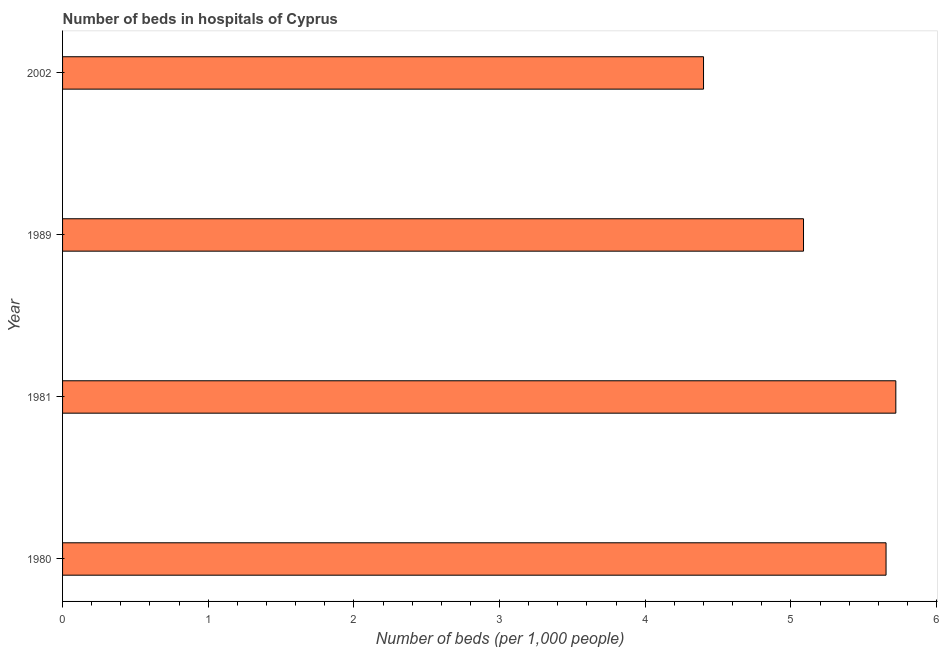Does the graph contain grids?
Ensure brevity in your answer.  No. What is the title of the graph?
Make the answer very short. Number of beds in hospitals of Cyprus. What is the label or title of the X-axis?
Make the answer very short. Number of beds (per 1,0 people). What is the label or title of the Y-axis?
Offer a very short reply. Year. What is the number of hospital beds in 2002?
Ensure brevity in your answer.  4.4. Across all years, what is the maximum number of hospital beds?
Give a very brief answer. 5.72. Across all years, what is the minimum number of hospital beds?
Your answer should be compact. 4.4. In which year was the number of hospital beds maximum?
Your answer should be compact. 1981. What is the sum of the number of hospital beds?
Your answer should be compact. 20.86. What is the difference between the number of hospital beds in 1980 and 2002?
Give a very brief answer. 1.25. What is the average number of hospital beds per year?
Your answer should be very brief. 5.21. What is the median number of hospital beds?
Offer a terse response. 5.37. In how many years, is the number of hospital beds greater than 5.6 %?
Provide a succinct answer. 2. Do a majority of the years between 2002 and 1989 (inclusive) have number of hospital beds greater than 3.4 %?
Provide a succinct answer. No. What is the ratio of the number of hospital beds in 1981 to that in 1989?
Keep it short and to the point. 1.12. Is the number of hospital beds in 1981 less than that in 2002?
Make the answer very short. No. Is the difference between the number of hospital beds in 1981 and 1989 greater than the difference between any two years?
Provide a short and direct response. No. What is the difference between the highest and the second highest number of hospital beds?
Your response must be concise. 0.07. What is the difference between the highest and the lowest number of hospital beds?
Give a very brief answer. 1.32. How many bars are there?
Offer a very short reply. 4. Are all the bars in the graph horizontal?
Offer a very short reply. Yes. Are the values on the major ticks of X-axis written in scientific E-notation?
Make the answer very short. No. What is the Number of beds (per 1,000 people) in 1980?
Make the answer very short. 5.65. What is the Number of beds (per 1,000 people) of 1981?
Your answer should be compact. 5.72. What is the Number of beds (per 1,000 people) in 1989?
Give a very brief answer. 5.09. What is the Number of beds (per 1,000 people) in 2002?
Make the answer very short. 4.4. What is the difference between the Number of beds (per 1,000 people) in 1980 and 1981?
Make the answer very short. -0.07. What is the difference between the Number of beds (per 1,000 people) in 1980 and 1989?
Your answer should be very brief. 0.57. What is the difference between the Number of beds (per 1,000 people) in 1980 and 2002?
Offer a terse response. 1.25. What is the difference between the Number of beds (per 1,000 people) in 1981 and 1989?
Your response must be concise. 0.63. What is the difference between the Number of beds (per 1,000 people) in 1981 and 2002?
Make the answer very short. 1.32. What is the difference between the Number of beds (per 1,000 people) in 1989 and 2002?
Provide a succinct answer. 0.69. What is the ratio of the Number of beds (per 1,000 people) in 1980 to that in 1989?
Offer a very short reply. 1.11. What is the ratio of the Number of beds (per 1,000 people) in 1980 to that in 2002?
Your answer should be very brief. 1.28. What is the ratio of the Number of beds (per 1,000 people) in 1981 to that in 2002?
Make the answer very short. 1.3. What is the ratio of the Number of beds (per 1,000 people) in 1989 to that in 2002?
Offer a terse response. 1.16. 